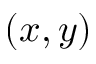<formula> <loc_0><loc_0><loc_500><loc_500>( x , y )</formula> 